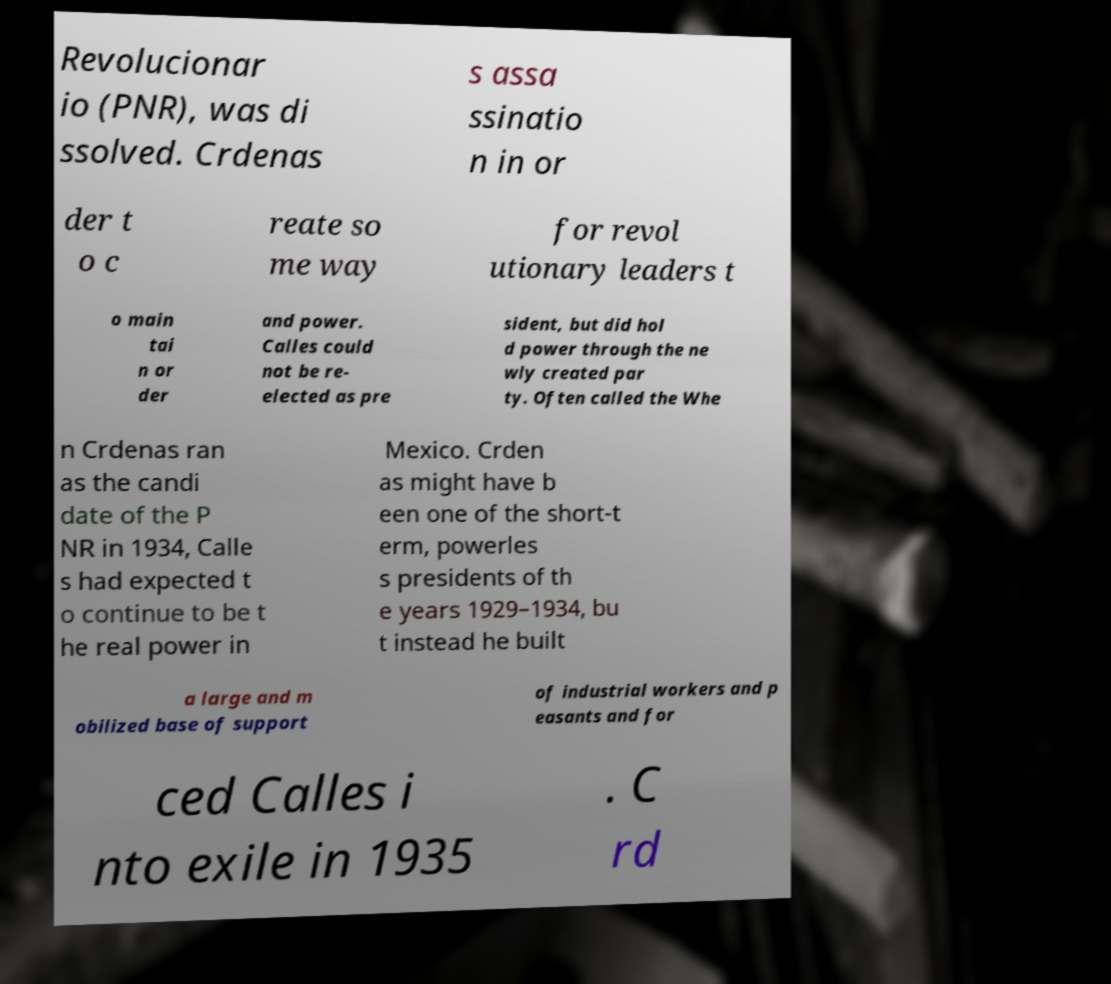What messages or text are displayed in this image? I need them in a readable, typed format. Revolucionar io (PNR), was di ssolved. Crdenas s assa ssinatio n in or der t o c reate so me way for revol utionary leaders t o main tai n or der and power. Calles could not be re- elected as pre sident, but did hol d power through the ne wly created par ty. Often called the Whe n Crdenas ran as the candi date of the P NR in 1934, Calle s had expected t o continue to be t he real power in Mexico. Crden as might have b een one of the short-t erm, powerles s presidents of th e years 1929–1934, bu t instead he built a large and m obilized base of support of industrial workers and p easants and for ced Calles i nto exile in 1935 . C rd 